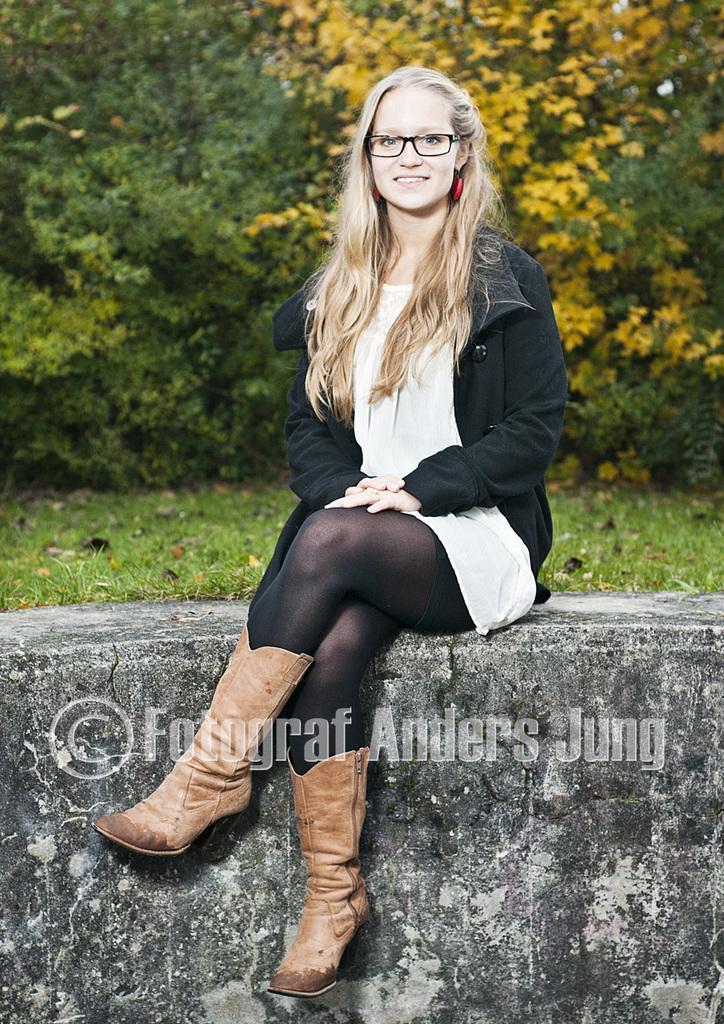Could you give a brief overview of what you see in this image? In this image we can see a woman. She is wearing a black color jacket and she is smiling. Here we can see the spectacles and here we can see the shoes. In the background, we can see the flowers and trees. Here we can see the grass. 